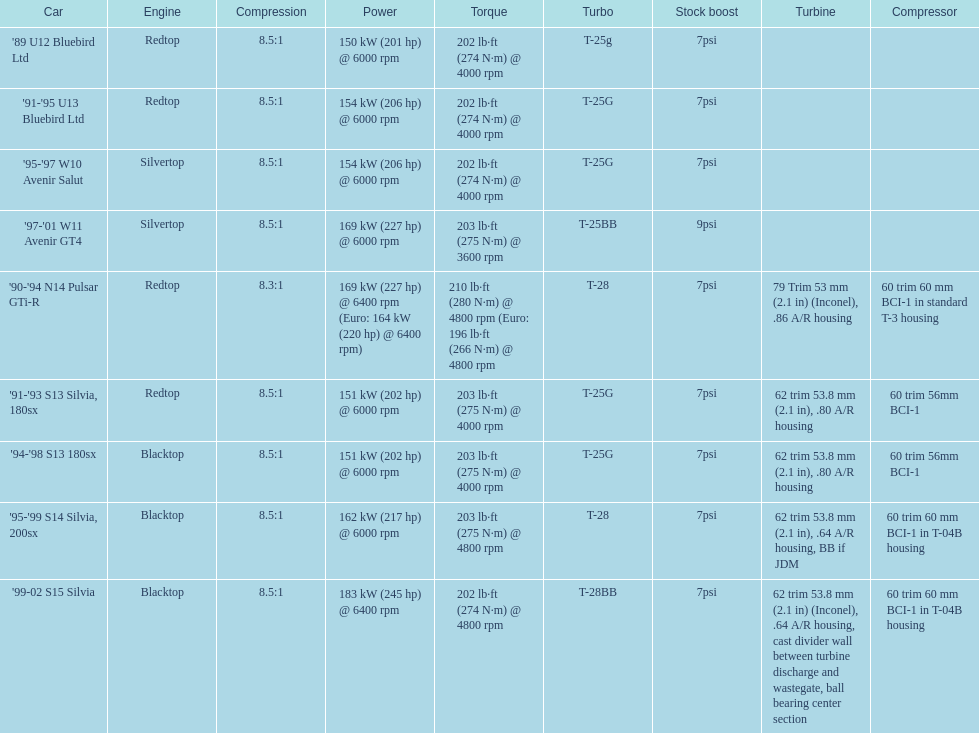Which motors are identical to the initial entry ('89 u12 bluebird ltd)? '91-'95 U13 Bluebird Ltd, '90-'94 N14 Pulsar GTi-R, '91-'93 S13 Silvia, 180sx. 